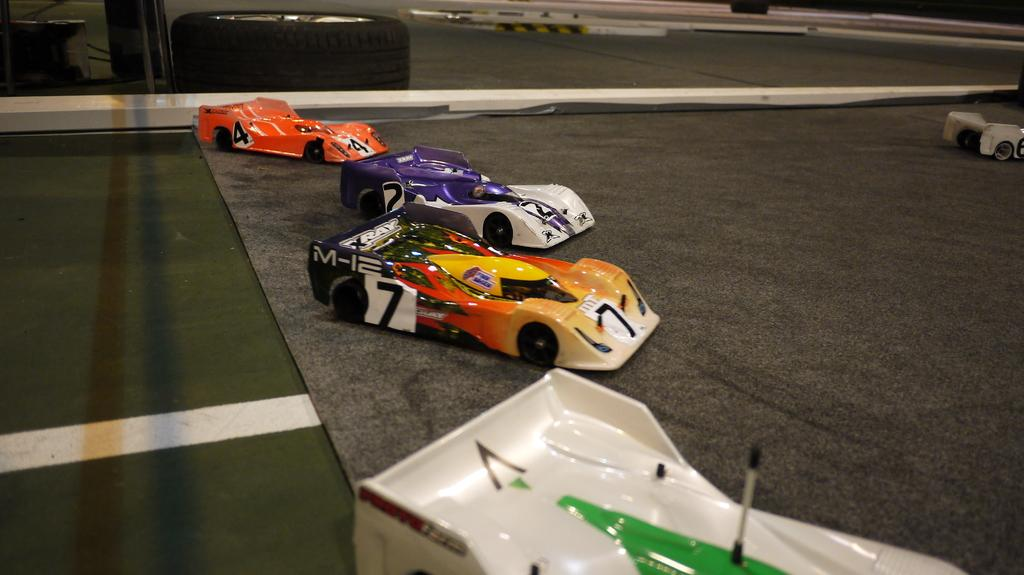What type of toys are on the carpet in the image? There are toy cars on the carpet in the image. Where is the carpet located? The carpet is on the floor. What can be seen in the background of the image? There is a glass door in the background, and a tire is visible behind it. Are there any other objects visible behind the glass door? Yes, there is at least one other object visible behind the glass door. What type of cork can be seen floating in the air behind the glass door? There is no cork visible in the image, and nothing is floating in the air. 